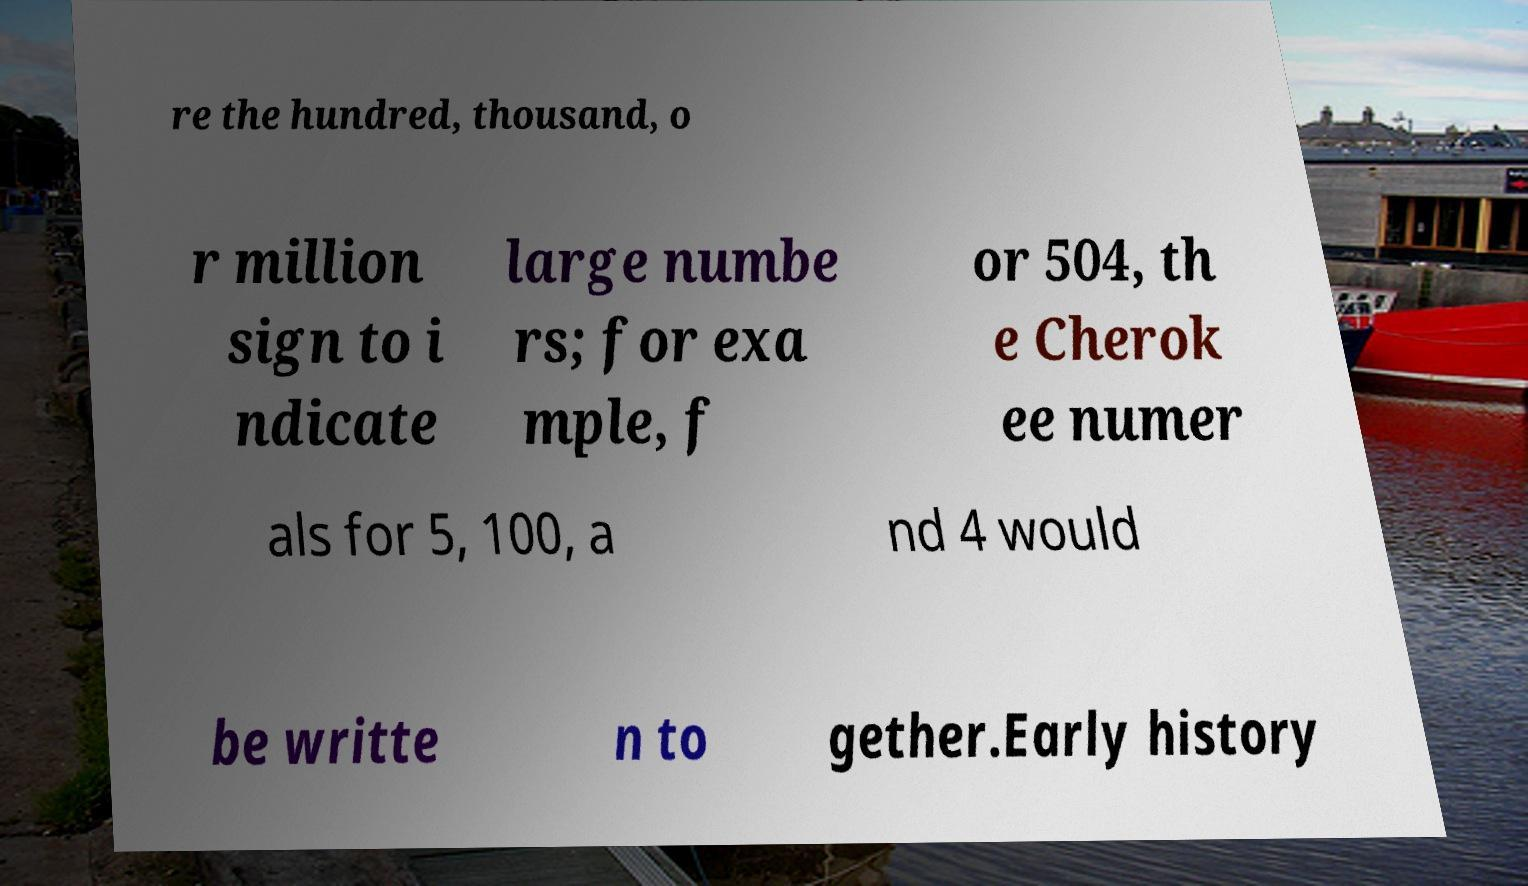Can you accurately transcribe the text from the provided image for me? re the hundred, thousand, o r million sign to i ndicate large numbe rs; for exa mple, f or 504, th e Cherok ee numer als for 5, 100, a nd 4 would be writte n to gether.Early history 